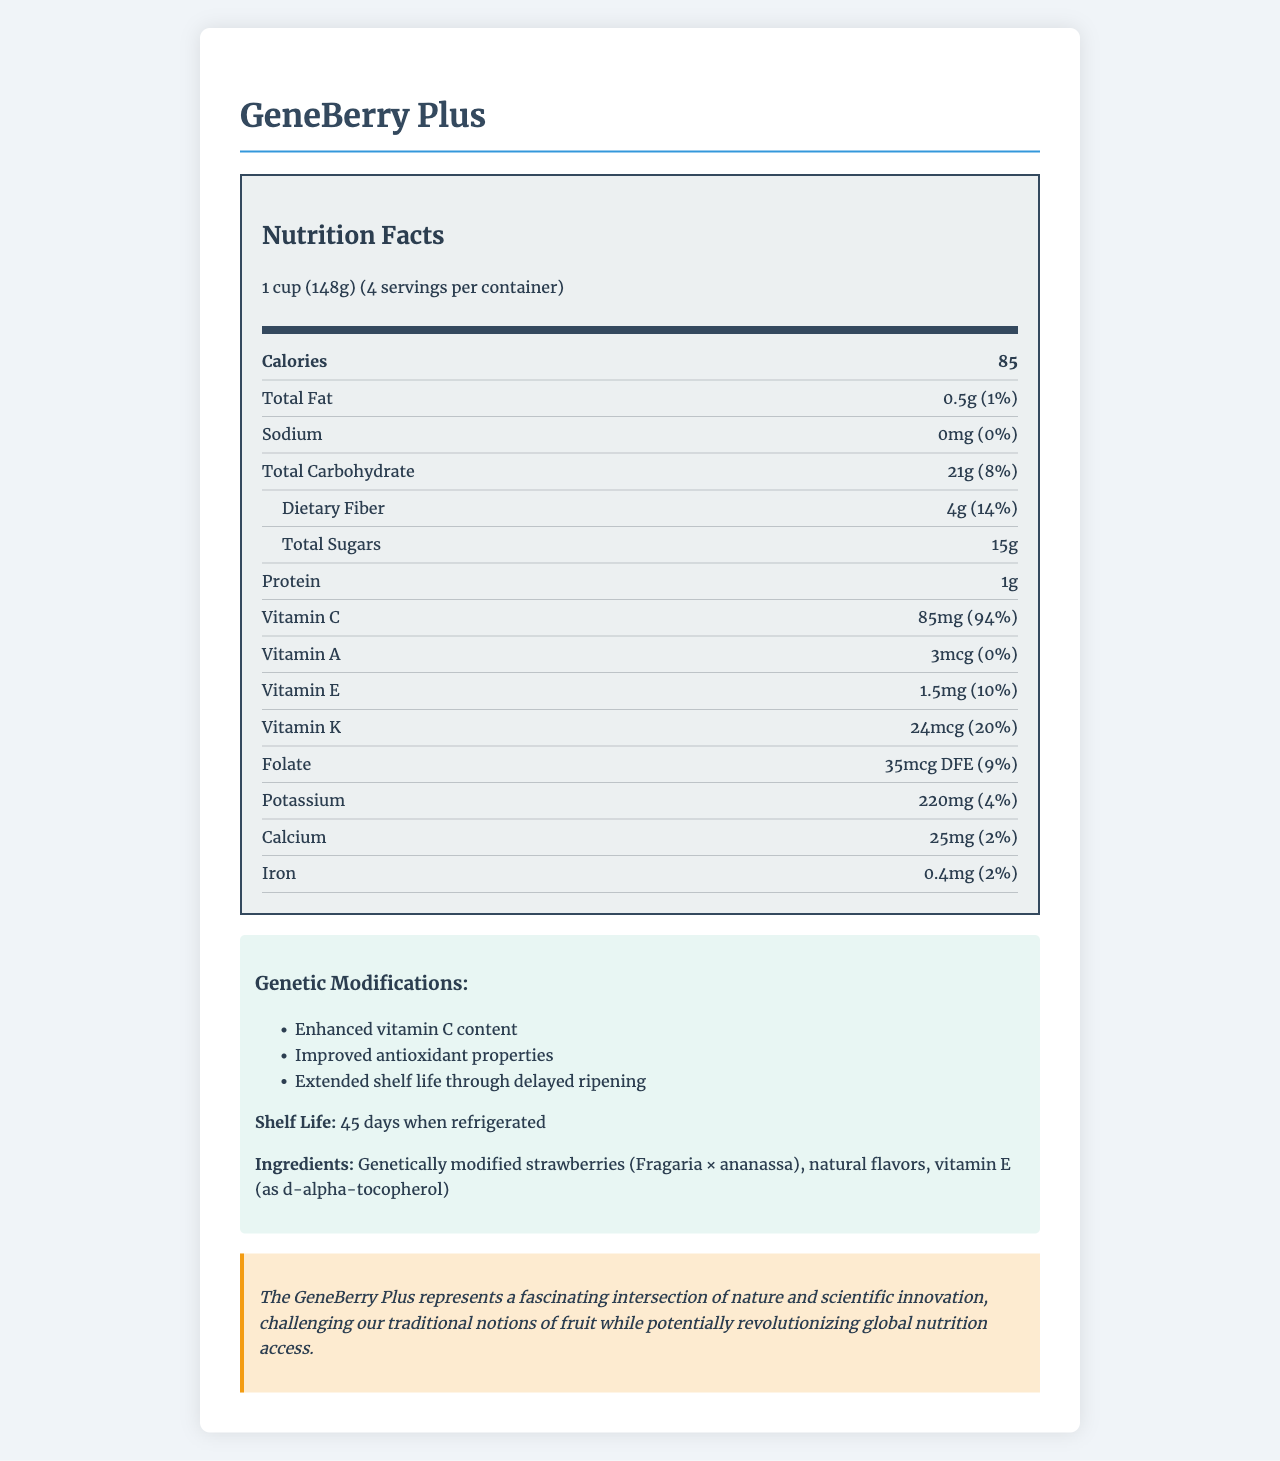what is the name of the product? The document title and content both clearly indicate that the product's name is "GeneBerry Plus".
Answer: GeneBerry Plus what is the shelf life of the GeneBerry Plus when refrigerated? In the modifications section of the document, it is mentioned that the shelf life is 45 days when refrigerated.
Answer: 45 days how many servings are there per container? The nutritional facts section shows that there are 4 servings per container.
Answer: 4 what is the amount of total fat per serving? In the nutritional information, it states that the total fat per serving is 0.5g, which is 1% of the daily value.
Answer: 0.5g (1%) what are the genetic modifications made to GeneBerry Plus? The modifications section lists three genetic modifications: Enhanced vitamin C content, Improved antioxidant properties, and Extended shelf life through delayed ripening.
Answer: Enhanced vitamin C content, Improved antioxidant properties, Extended shelf life through delayed ripening how much protein does one serving of GeneBerry Plus contain? The nutritional facts indicate that there is 1g of protein per serving.
Answer: 1g did they enhance the vitamin C content of the GeneBerry Plus? In the modifications section, it confirms that one of the genetic modifications is "Enhanced vitamin C content."
Answer: Yes how many calories are in one serving of GeneBerry Plus? The document states that one serving (1 cup, 148g) of GeneBerry Plus contains 85 calories.
Answer: 85 which vitamin has the highest daily value percentage in GeneBerry Plus? A. Vitamin A B. Vitamin E C. Vitamin C D. Vitamin K The vitamin section of the nutrition facts shows that Vitamin C has a daily value percentage of 94%, which is the highest among the listed vitamins.
Answer: C. Vitamin C what is the daily value percentage of dietary fiber in GeneBerry Plus? The nutritional facts indicate that the dietary fiber content per serving is 4g, which is 14% of the daily value.
Answer: 14% does the document specify the origin of the strawberries used in GeneBerry Plus? The document does not provide any information regarding the origin of the strawberries.
Answer: No what are the highlighted benefits of GeneBerry Plus from a literary perspective? The literary perspective section elaborates on how GeneBerry Plus represents a blend of nature and science, challenges traditional notions of fruit, and could revolutionize global nutrition access.
Answer: Fascination intersection of nature and scientific innovation, challenging traditional notions of fruit, potentially revolutionizing global nutrition access what is the folate content per serving, and its daily value percentage? The nutrition facts indicate that the folate content per serving is 35mcg DFE, which is 9% of the daily value.
Answer: 35mcg DFE, 9% how much sodium does GeneBerry Plus contain per serving? A. 0mg B. 15mg C. 20mg D. 25mg The nutrition facts state that there is 0mg of sodium per serving.
Answer: A. 0mg describe the main idea of the document. The document includes nutritional details, genetic enhancements, shelf life, ingredients, and a literary perspective on the product, showcasing both its scientific advancements and potential benefits in terms of nutrition.
Answer: The document provides detailed nutritional information and genetic modifications of GeneBerry Plus, a genetically modified fruit with enhanced vitamin content and extended shelf life, displaying its innovative qualities and potential impact on global nutrition. which vitamins and minerals are listed in the GeneBerry Plus nutrition label? The nutrition label lists Vitamin C, A, E, K, Folate, Potassium, Calcium, and Iron, along with their respective amounts and daily values.
Answer: Vitamin C, Vitamin A, Vitamin E, Vitamin K, Folate, Potassium, Calcium, Iron 